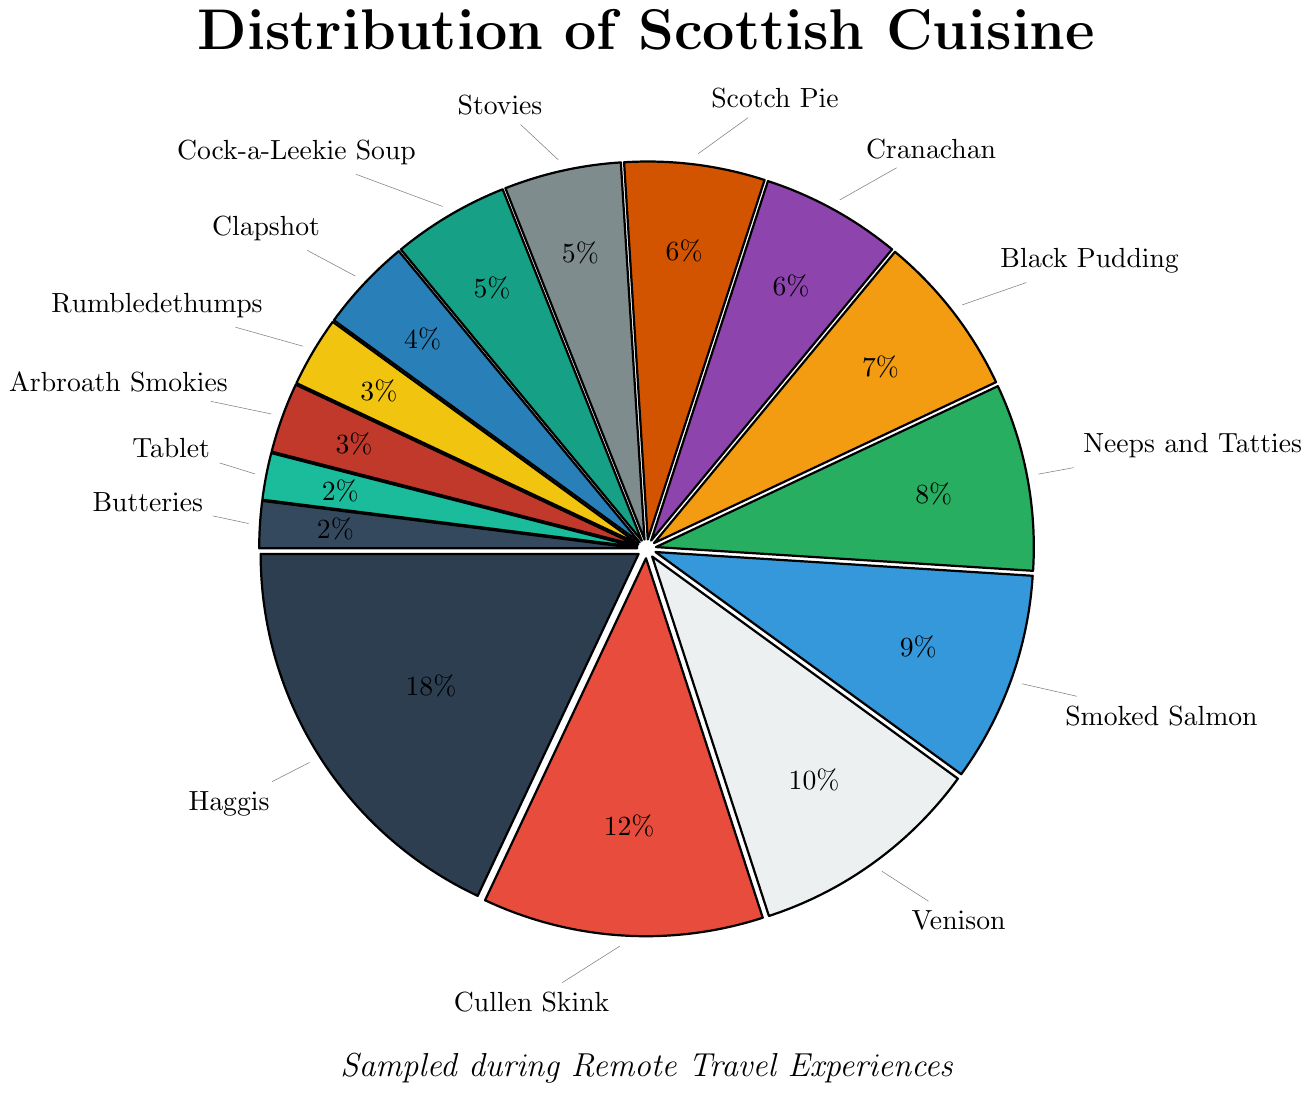Which cuisine type has the highest percentage sampled? The slice with the largest relative size is labeled "Haggis," indicating it has the highest percentage among the cuisine types.
Answer: Haggis Which cuisine types have the smallest percentage sampled? The slices with the smallest sizes are labeled "Tablet" and "Butteries," both indicating they have the smallest percentage among the cuisine types.
Answer: Tablet and Butteries What is the combined percentage for Haggis, Cullen Skink, and Venison? Add the percentages of Haggis (18%), Cullen Skink (12%), and Venison (10%): 18 + 12 + 10 = 40%.
Answer: 40% Which has a higher percentage, Cranachan or Scotch Pie? Both Cranachan and Scotch Pie have equal slice sizes, indicating both have 6%.
Answer: Both are equal What is the total percentage for the top five cuisines sampled? Add the percentages of the top five cuisines: Haggis (18%), Cullen Skink (12%), Venison (10%), Smoked Salmon (9%), and Neeps and Tatties (8%): 18 + 12 + 10 + 9 + 8 = 57%.
Answer: 57% How does the percentage of Smoked Salmon compare to that of Cock-a-Leekie Soup? Smoked Salmon has a slice size labeled as 9%, while Cock-a-Leekie Soup has a slice size labeled as 5%. Since 9% is greater than 5%, Smoked Salmon has a higher percentage.
Answer: Smoked Salmon is higher What is the median percentage value among all cuisine types? To find the median, list all cuisine percentages in ascending order: 2, 2, 3, 3, 4, 5, 5, 6, 6, 7, 8, 9, 10, 12, 18. The middle value is the eighth one: 6%.
Answer: 6% What is the difference in percentage between Black Pudding and Stovies? Subtract the percentage of Stovies (5%) from Black Pudding (7%): 7 - 5 = 2%.
Answer: 2% Which cuisine type ranks just above Stovies in percentage? The cuisine types in increasing order include Stovies at 5% and before it is Cranachan and Scotch Pie each at 6%. Thus, the one just above is either Cranachan or Scotch Pie.
Answer: Cranachan or Scotch Pie What percentage of cuisines have a slice size of exactly 4% or less? Count the cuisines with slice sizes equal to or below 4%: Clapshot (4%), Rumbledethumps (3%), Arbroath Smokies (3%), Tablet (2%), Butteries (2%). There are five such cuisines. With 15 cuisines in total, the percentage is (5/15) * 100% = 33.33%.
Answer: 33.33% 